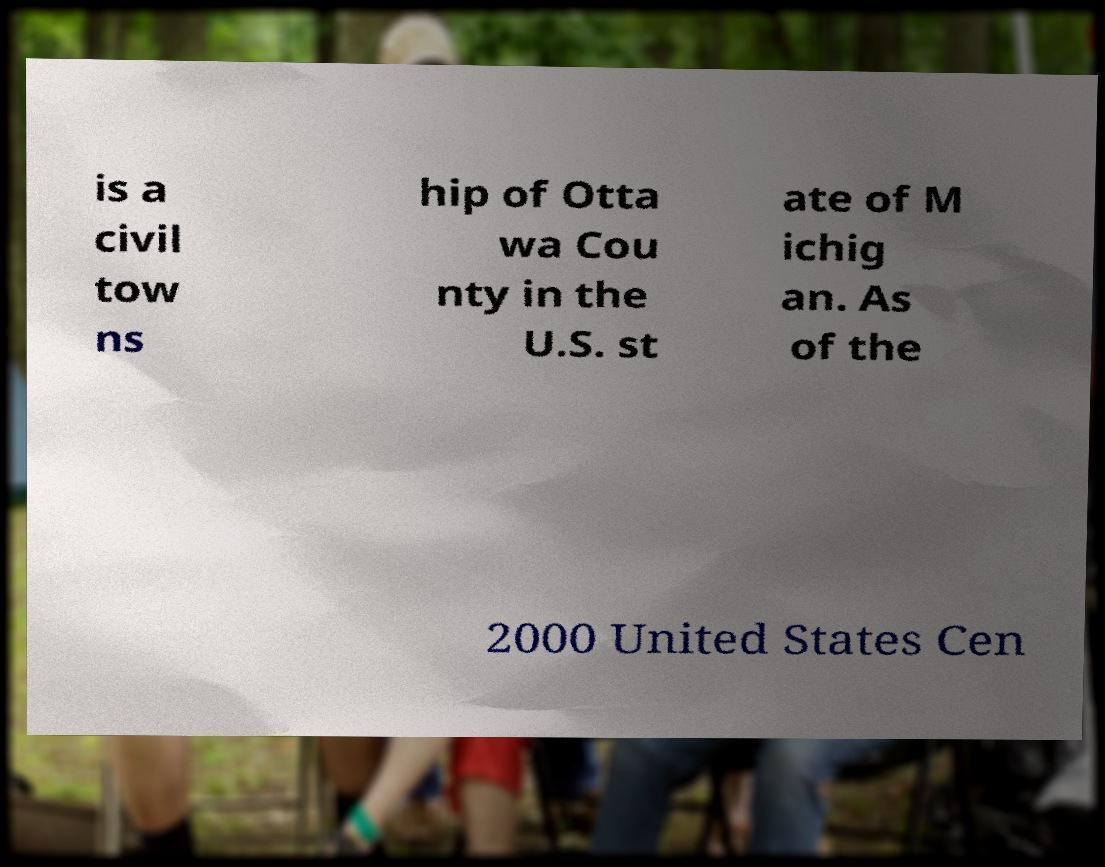For documentation purposes, I need the text within this image transcribed. Could you provide that? is a civil tow ns hip of Otta wa Cou nty in the U.S. st ate of M ichig an. As of the 2000 United States Cen 